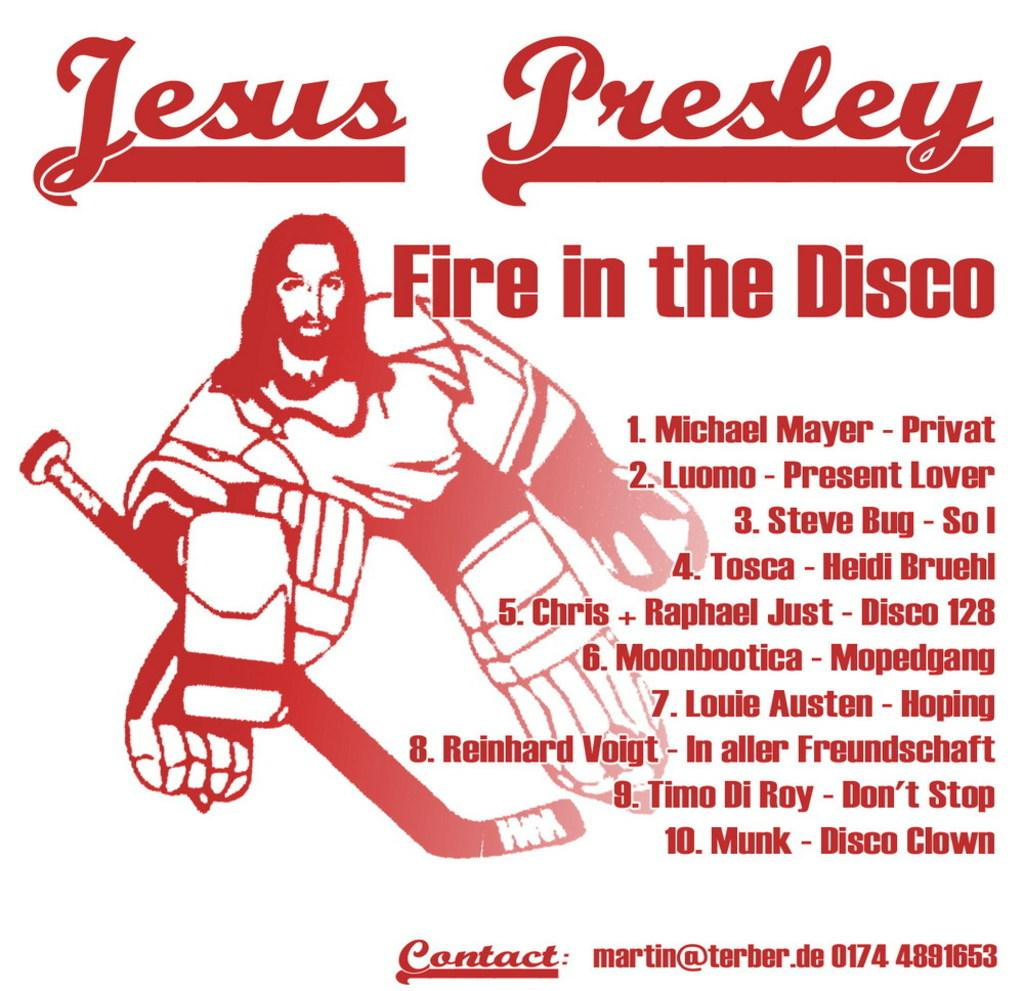<image>
Write a terse but informative summary of the picture. Jesus Presley is printed in red above a picture of a hockey player. 